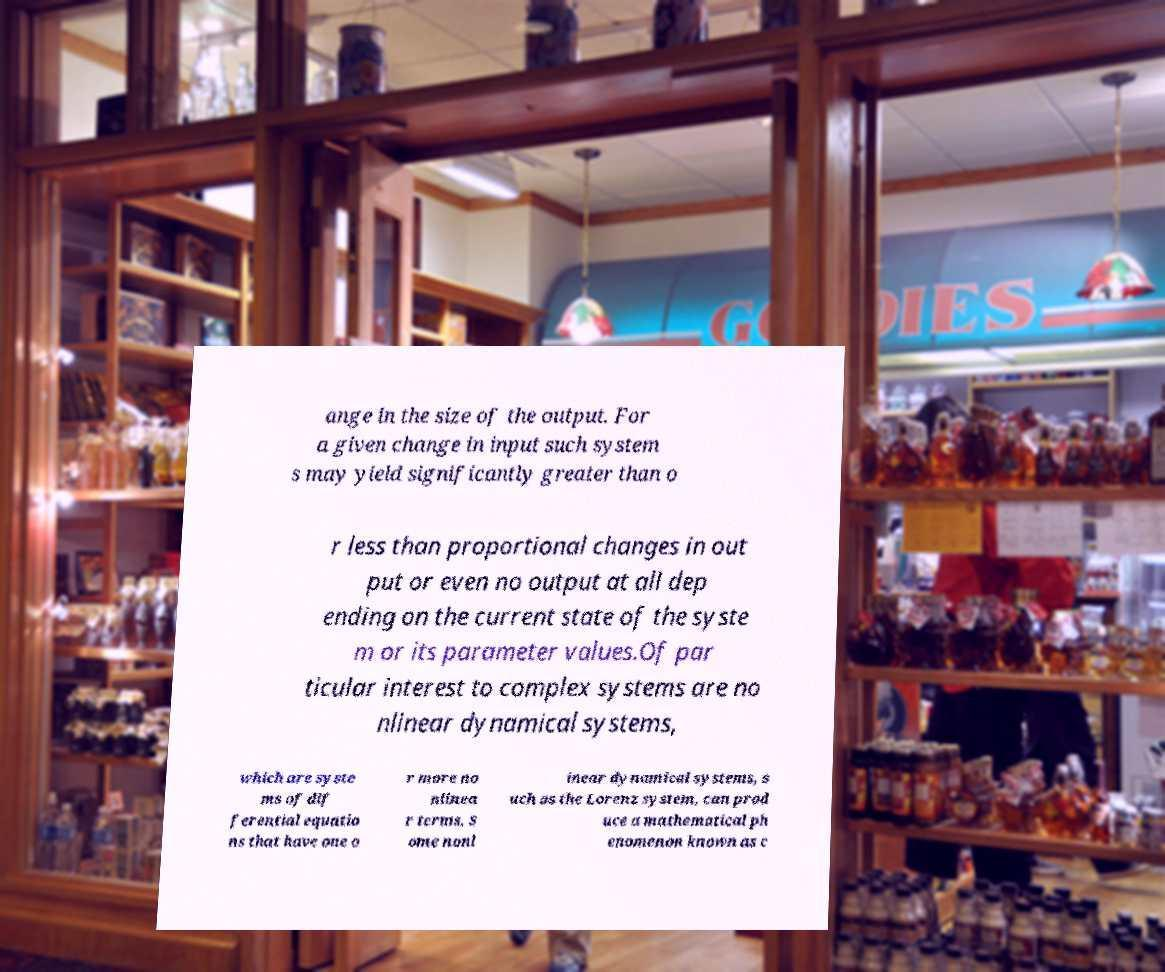Could you extract and type out the text from this image? ange in the size of the output. For a given change in input such system s may yield significantly greater than o r less than proportional changes in out put or even no output at all dep ending on the current state of the syste m or its parameter values.Of par ticular interest to complex systems are no nlinear dynamical systems, which are syste ms of dif ferential equatio ns that have one o r more no nlinea r terms. S ome nonl inear dynamical systems, s uch as the Lorenz system, can prod uce a mathematical ph enomenon known as c 